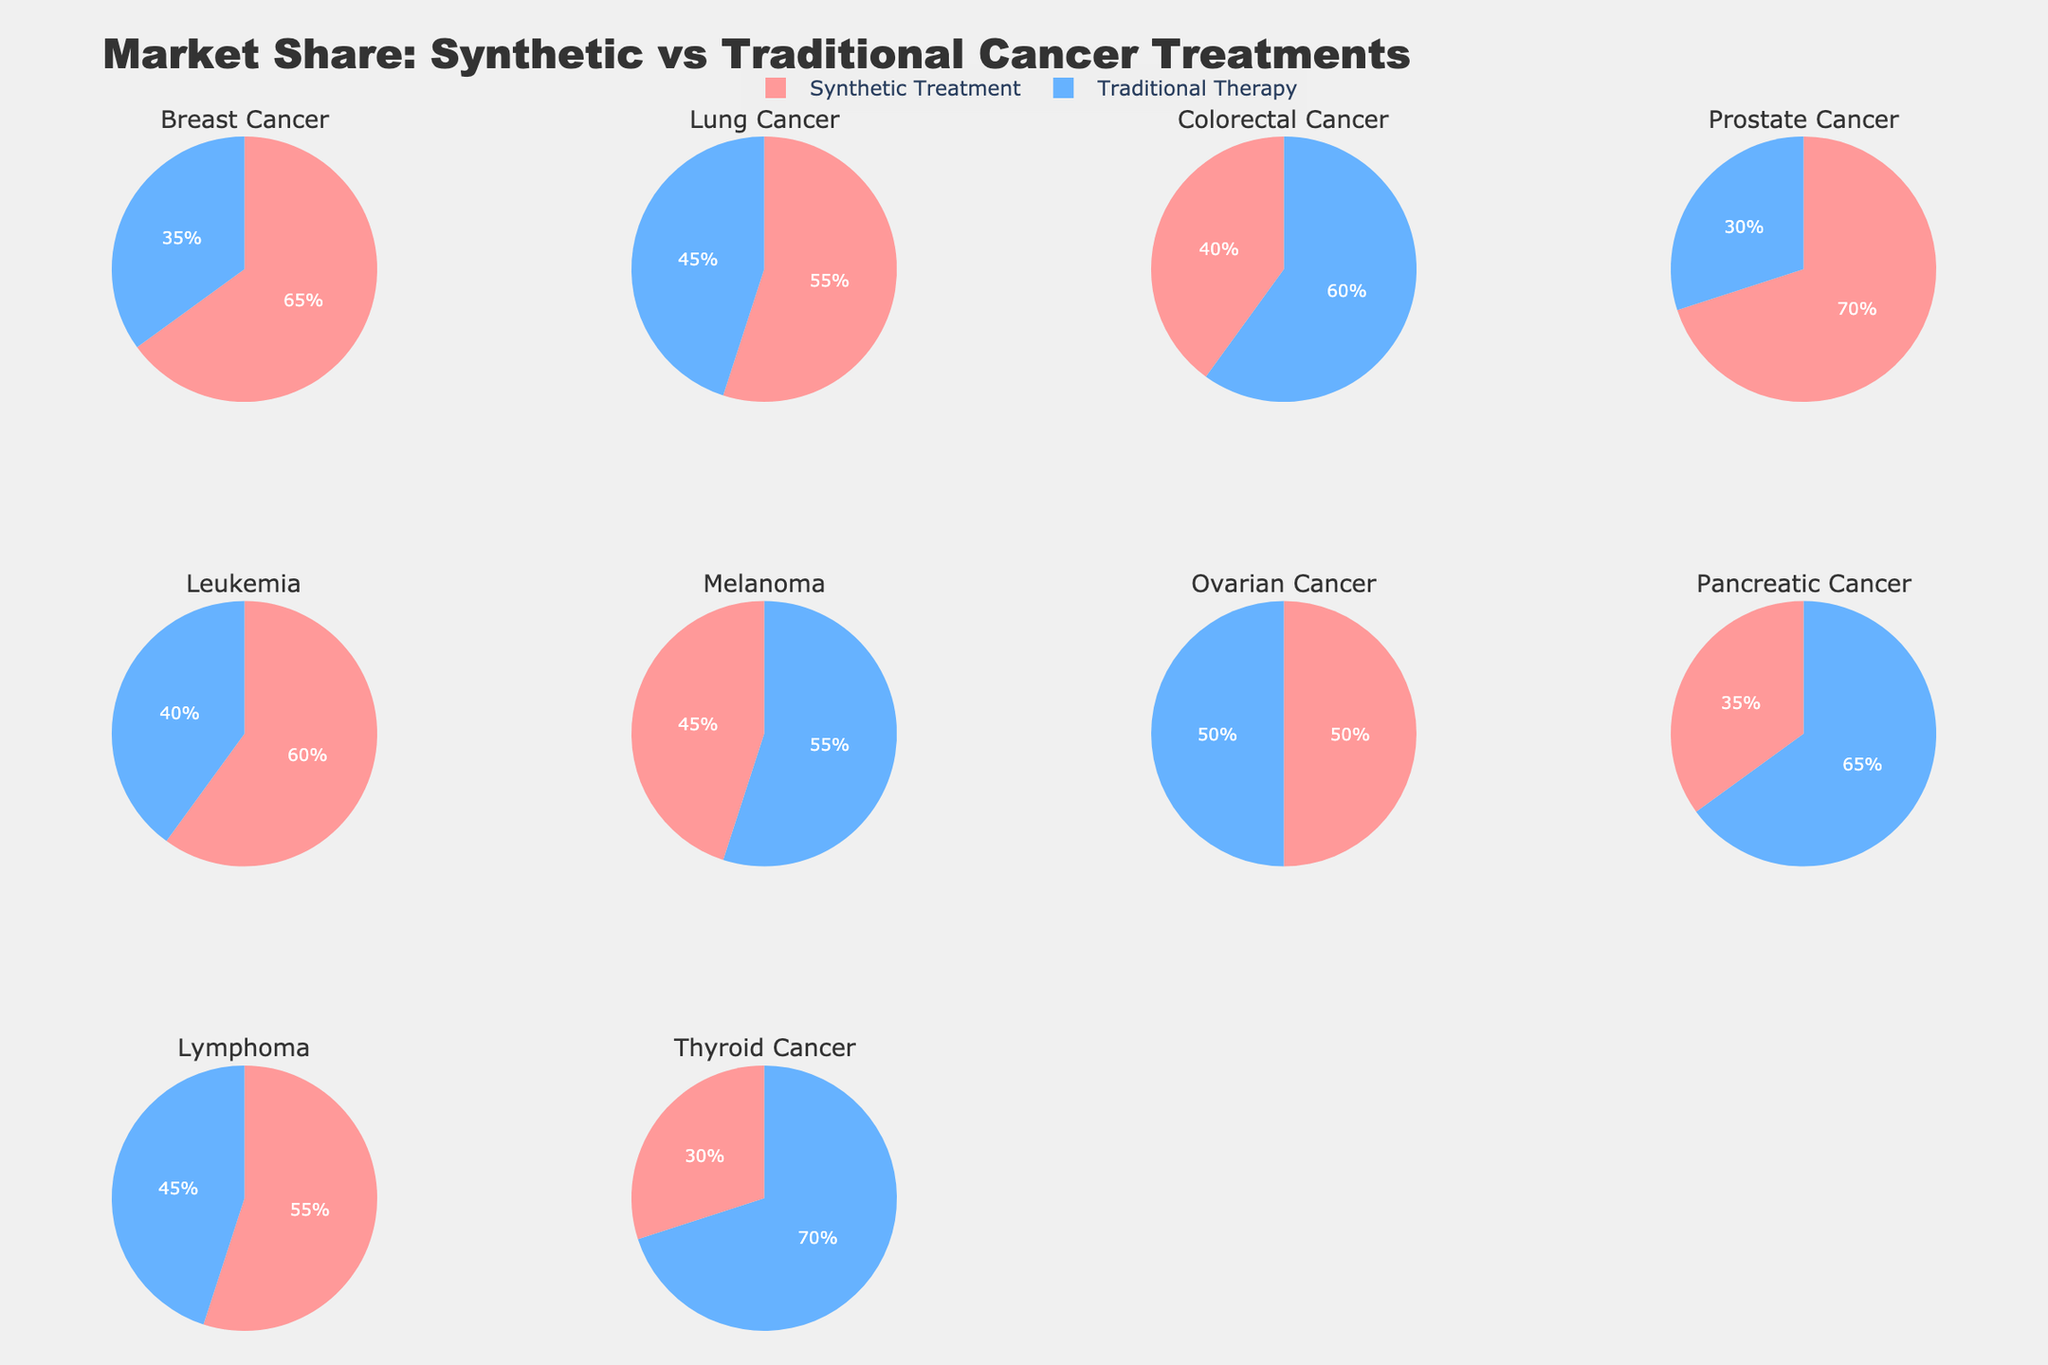what's the title of the plot? The title is located at the top of the subplot and typically describes the overall theme or subject of the figure. In this case, it reads "Market Share: Synthetic vs Traditional Cancer Treatments".
Answer: Market Share: Synthetic vs Traditional Cancer Treatments how many pie charts are there in the figure? Each pie chart represents a different cancer type, and there are individual subplots for each type. Counting the subplots, there are 10 in total.
Answer: 10 which cancer type has the highest market share for synthetic treatment? To determine this, look at each pie chart and identify the segment representing synthetic treatment, then compare the percentages. The highest value is for Prostate Cancer at 70%.
Answer: Prostate Cancer which two cancer types have equal market shares for synthetic treatment and traditional therapy? Review the segments in every pie chart. Both segments' percentages must add up to 100% and be equal. Ovarian Cancer's pie chart has equal market shares of 50% each.
Answer: Ovarian Cancer which cancer type has the lowest market share for synthetic treatment? Check each pie chart for the smallest percentage of the synthetic treatment segment. Thyroid Cancer has the lowest at 30%.
Answer: Thyroid Cancer what is the difference in market share between synthetic treatment and traditional therapy for breast cancer? For Breast Cancer, synthetic treatment has 65% and traditional therapy has 35%. The difference is 65% - 35% = 30%.
Answer: 30% how many cancer types have synthetic treatments with a market share greater than 50%? Go through each pie chart and count the ones where the synthetic treatment segment exceeds 50%. There are five such types: Breast Cancer, Lung Cancer, Prostate Cancer, Leukemia, and Lymphoma.
Answer: 5 what is the combined market share percentage of synthetic treatments for breast cancer and lung cancer? Sum the synthetic treatment percentages for both cancer types: Breast Cancer (65%) + Lung Cancer (55%) = 120%.
Answer: 120% which cancer type has traditional therapy as the most dominant treatment option? Look for the pie chart where the traditional therapy segment is the largest. Thyroid Cancer has the highest traditional therapy share at 70%.
Answer: Thyroid Cancer which cancer type shows the closest market share percentages between synthetic treatment and traditional therapy other than ovarian cancer? Identify the pie chart where the percentages of synthetic and traditional therapies are closest to each other, excluding the equal share in Ovarian Cancer. The smallest difference is observed in Melanoma with 45% (Synthetic) vs 55% (Traditional), a 10% difference.
Answer: Melanoma 